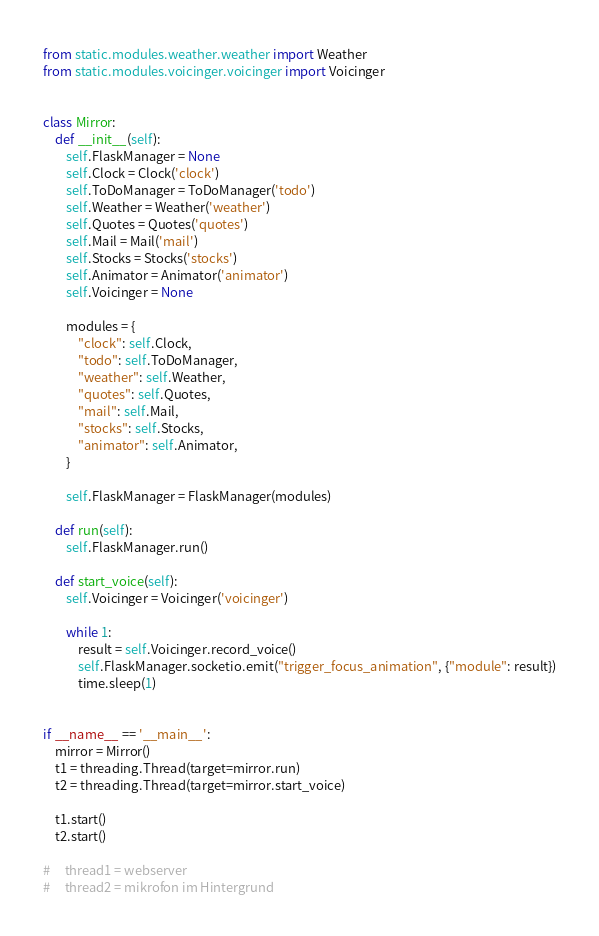<code> <loc_0><loc_0><loc_500><loc_500><_Python_>from static.modules.weather.weather import Weather
from static.modules.voicinger.voicinger import Voicinger


class Mirror:
    def __init__(self):
        self.FlaskManager = None
        self.Clock = Clock('clock')
        self.ToDoManager = ToDoManager('todo')
        self.Weather = Weather('weather')
        self.Quotes = Quotes('quotes')
        self.Mail = Mail('mail')
        self.Stocks = Stocks('stocks')
        self.Animator = Animator('animator')
        self.Voicinger = None

        modules = {
            "clock": self.Clock,
            "todo": self.ToDoManager,
            "weather": self.Weather,
            "quotes": self.Quotes,
            "mail": self.Mail,
            "stocks": self.Stocks,
            "animator": self.Animator,
        }

        self.FlaskManager = FlaskManager(modules)

    def run(self):
        self.FlaskManager.run()

    def start_voice(self):
        self.Voicinger = Voicinger('voicinger')

        while 1:
            result = self.Voicinger.record_voice()
            self.FlaskManager.socketio.emit("trigger_focus_animation", {"module": result})
            time.sleep(1)


if __name__ == '__main__':
    mirror = Mirror()
    t1 = threading.Thread(target=mirror.run)
    t2 = threading.Thread(target=mirror.start_voice)

    t1.start()
    t2.start()

#     thread1 = webserver
#     thread2 = mikrofon im Hintergrund
</code> 